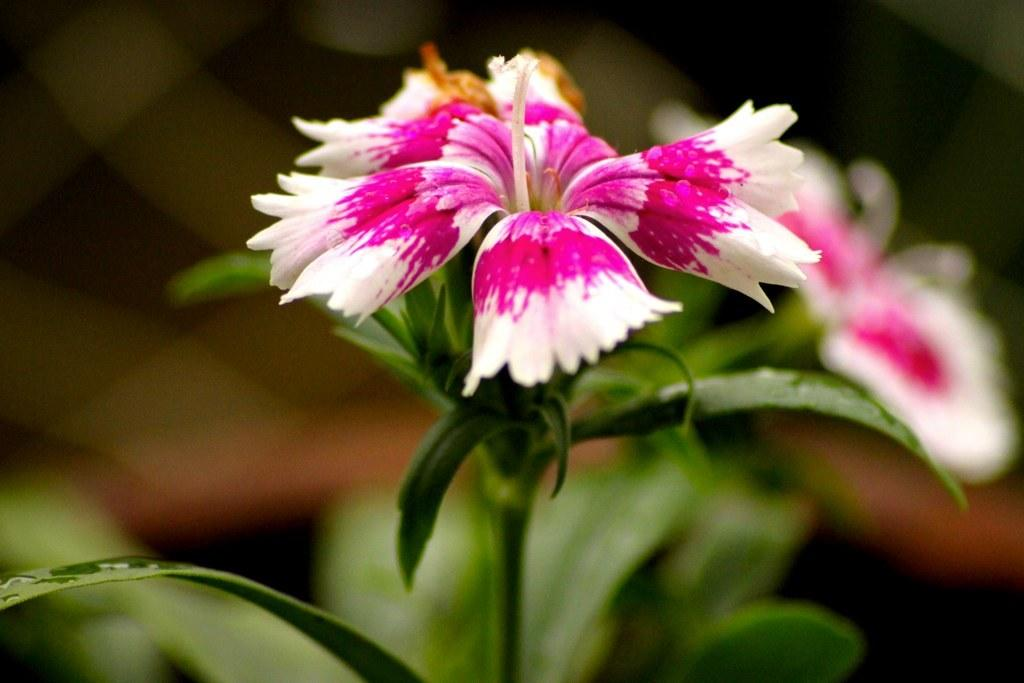What type of plants can be seen in the image? There are flowers and leaves in the image. Can you describe the background of the image? The background of the image is blurred. How many cows are visible in the image? There are no cows present in the image; it features flowers and leaves with a blurred background. 